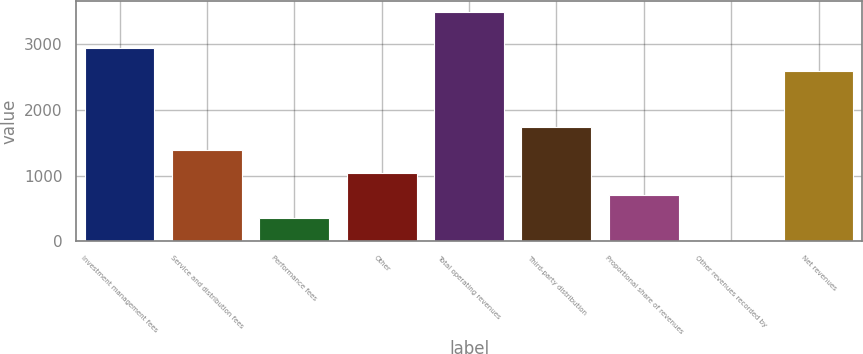Convert chart to OTSL. <chart><loc_0><loc_0><loc_500><loc_500><bar_chart><fcel>Investment management fees<fcel>Service and distribution fees<fcel>Performance fees<fcel>Other<fcel>Total operating revenues<fcel>Third-party distribution<fcel>Proportional share of revenues<fcel>Other revenues recorded by<fcel>Net revenues<nl><fcel>2950.94<fcel>1395.26<fcel>349.04<fcel>1046.52<fcel>3487.7<fcel>1744<fcel>697.78<fcel>0.3<fcel>2602.2<nl></chart> 